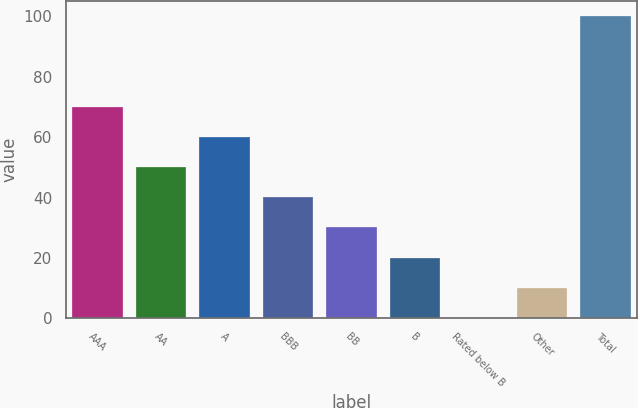Convert chart. <chart><loc_0><loc_0><loc_500><loc_500><bar_chart><fcel>AAA<fcel>AA<fcel>A<fcel>BBB<fcel>BB<fcel>B<fcel>Rated below B<fcel>Other<fcel>Total<nl><fcel>70.06<fcel>50.1<fcel>60.08<fcel>40.12<fcel>30.14<fcel>20.16<fcel>0.2<fcel>10.18<fcel>100<nl></chart> 